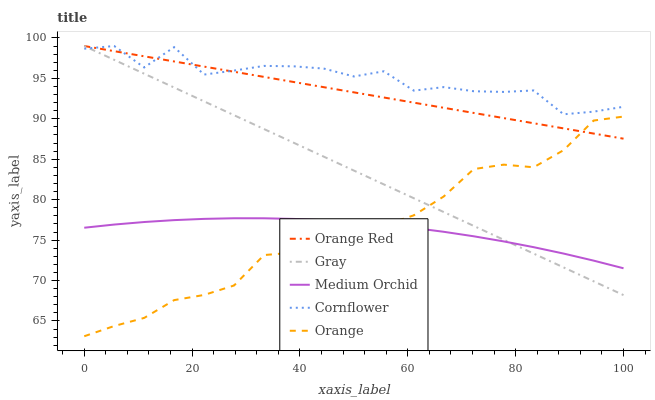Does Medium Orchid have the minimum area under the curve?
Answer yes or no. Yes. Does Cornflower have the maximum area under the curve?
Answer yes or no. Yes. Does Gray have the minimum area under the curve?
Answer yes or no. No. Does Gray have the maximum area under the curve?
Answer yes or no. No. Is Gray the smoothest?
Answer yes or no. Yes. Is Cornflower the roughest?
Answer yes or no. Yes. Is Medium Orchid the smoothest?
Answer yes or no. No. Is Medium Orchid the roughest?
Answer yes or no. No. Does Orange have the lowest value?
Answer yes or no. Yes. Does Gray have the lowest value?
Answer yes or no. No. Does Cornflower have the highest value?
Answer yes or no. Yes. Does Medium Orchid have the highest value?
Answer yes or no. No. Is Orange less than Cornflower?
Answer yes or no. Yes. Is Cornflower greater than Orange?
Answer yes or no. Yes. Does Gray intersect Orange Red?
Answer yes or no. Yes. Is Gray less than Orange Red?
Answer yes or no. No. Is Gray greater than Orange Red?
Answer yes or no. No. Does Orange intersect Cornflower?
Answer yes or no. No. 